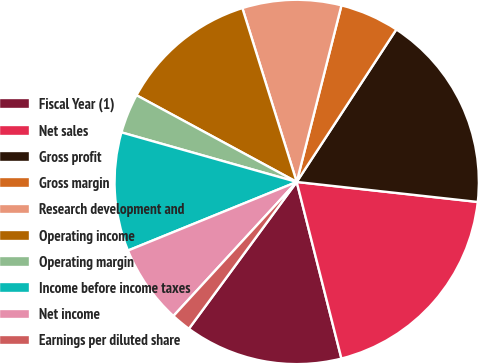Convert chart to OTSL. <chart><loc_0><loc_0><loc_500><loc_500><pie_chart><fcel>Fiscal Year (1)<fcel>Net sales<fcel>Gross profit<fcel>Gross margin<fcel>Research development and<fcel>Operating income<fcel>Operating margin<fcel>Income before income taxes<fcel>Net income<fcel>Earnings per diluted share<nl><fcel>14.03%<fcel>19.3%<fcel>17.54%<fcel>5.26%<fcel>8.77%<fcel>12.28%<fcel>3.51%<fcel>10.53%<fcel>7.02%<fcel>1.75%<nl></chart> 